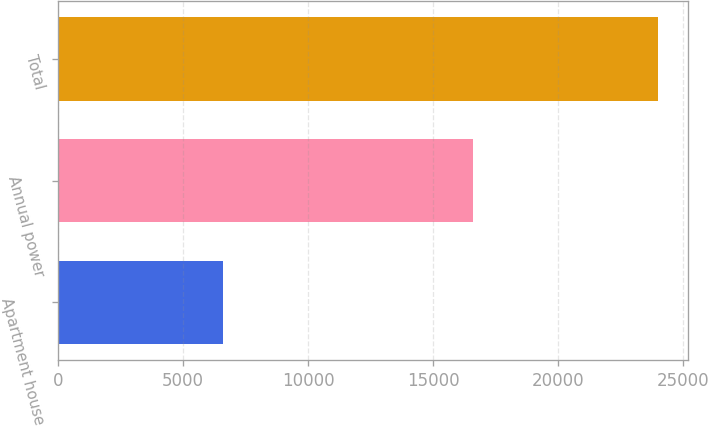Convert chart. <chart><loc_0><loc_0><loc_500><loc_500><bar_chart><fcel>Apartment house<fcel>Annual power<fcel>Total<nl><fcel>6614<fcel>16577<fcel>23976<nl></chart> 